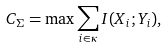Convert formula to latex. <formula><loc_0><loc_0><loc_500><loc_500>C _ { \Sigma } = \max \sum _ { i \in \kappa } I ( X _ { i } ; Y _ { i } ) ,</formula> 